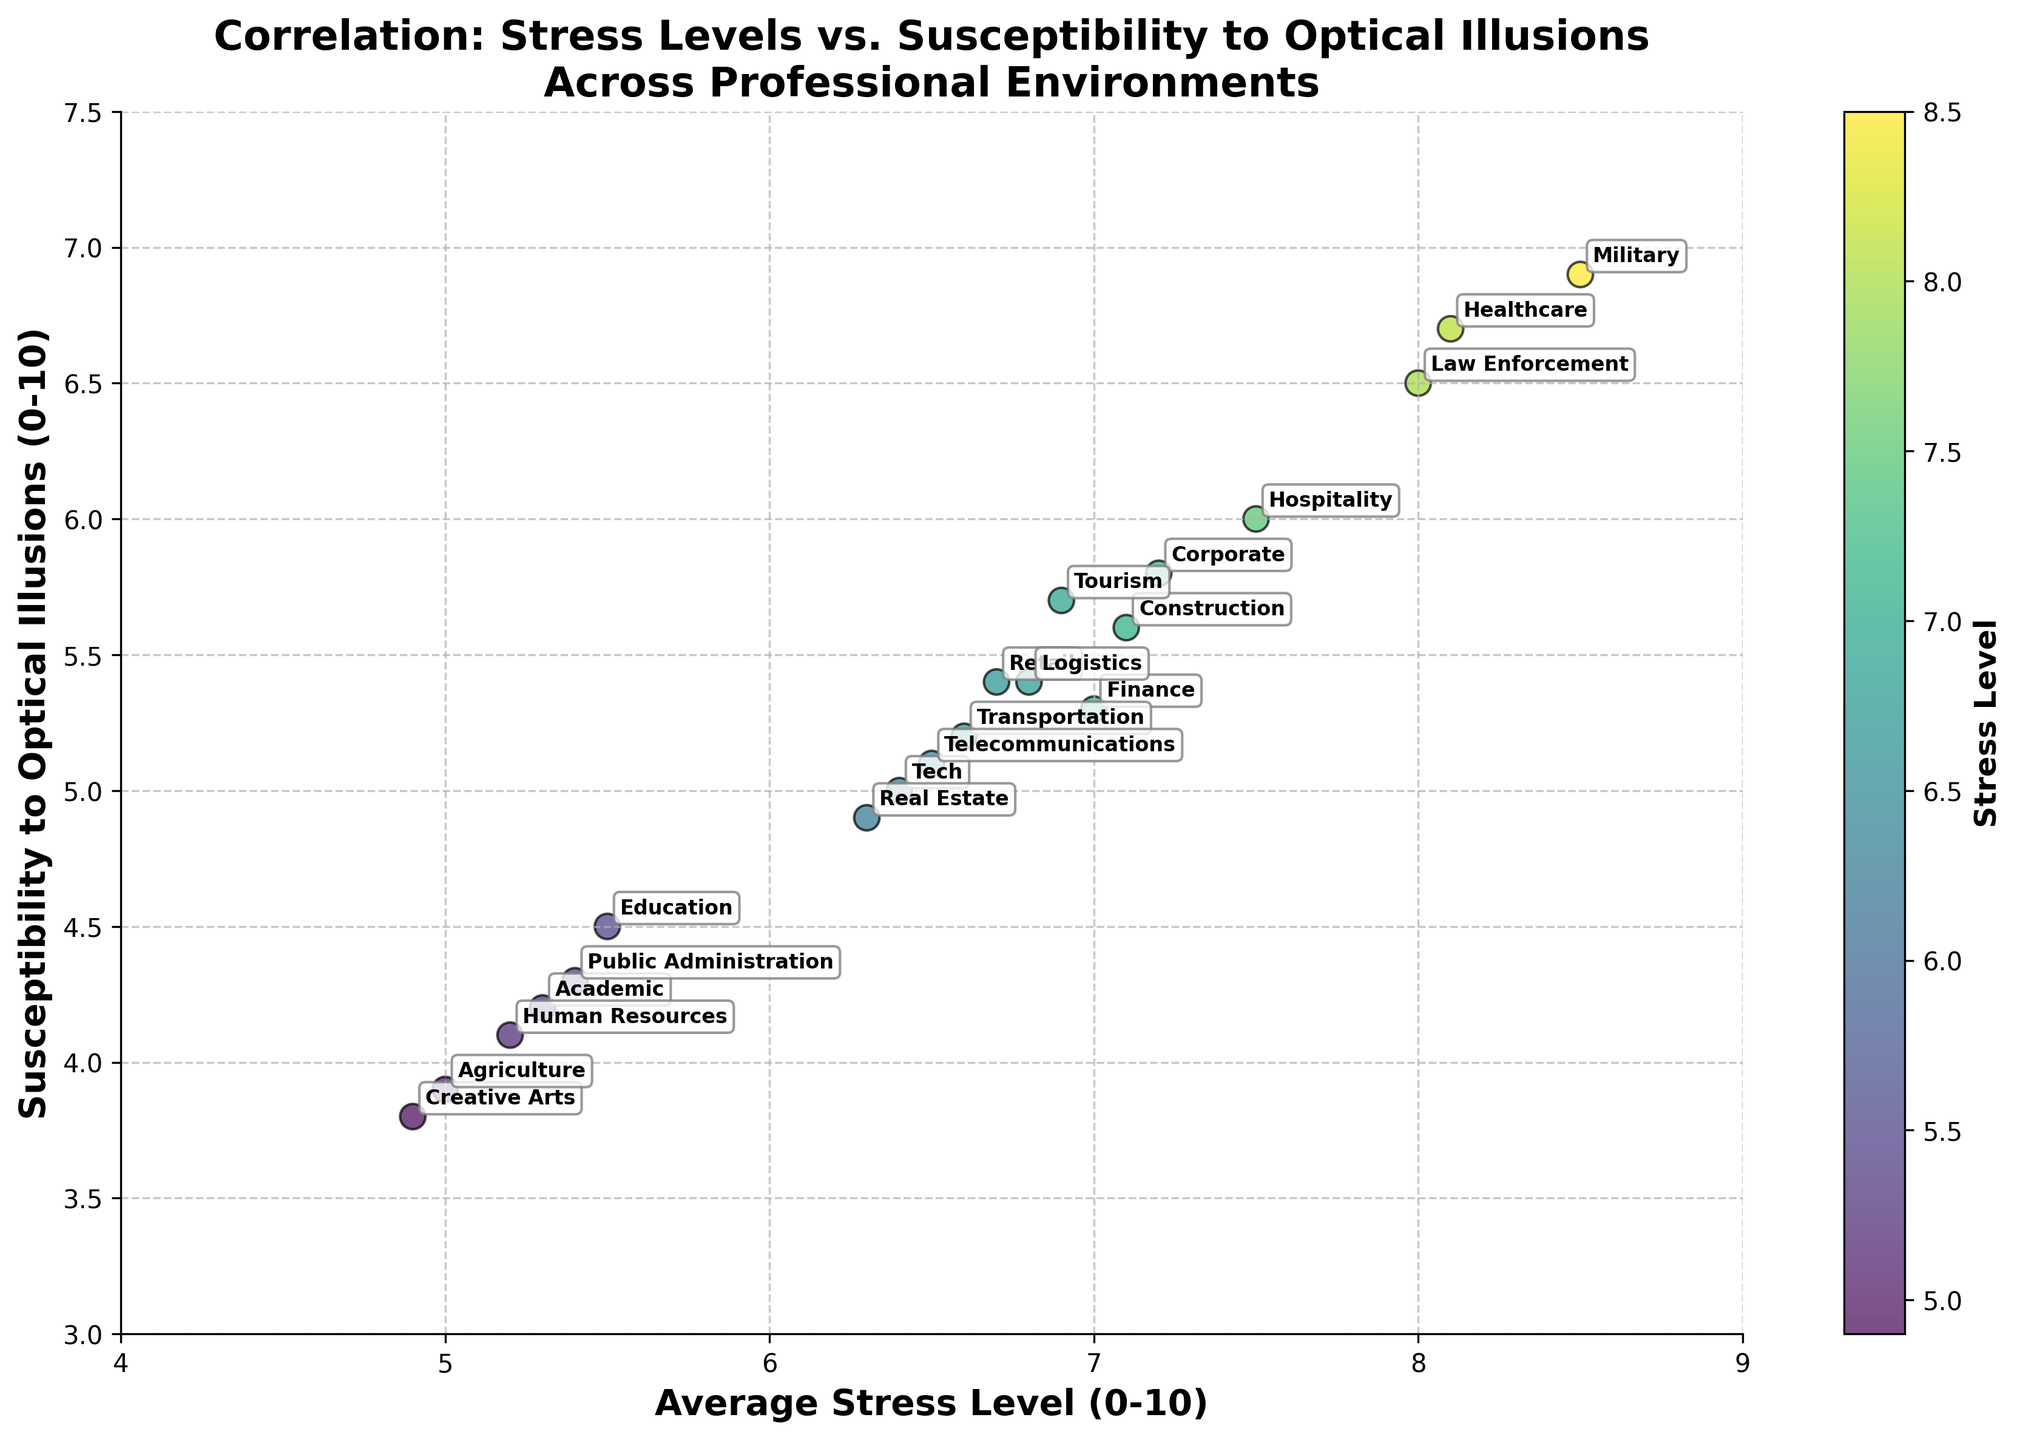How many professional environments are represented in the scatter plot? The scatter plot shows dots annotated with different professional environments. By counting the annotations, we can determine the number of represented environments.
Answer: 20 What is the correlation between stress levels and susceptibility to optical illusions? By observing the trend in the scatter plot, it appears that higher stress levels are associated with higher susceptibility to optical illusions, indicating a positive correlation.
Answer: Positive correlation Which professional environment has the highest average stress level? Look at the data points along the x-axis labeled with average stress levels. Identify the point with the highest x-axis value and note its annotation.
Answer: Military Which professional environment has the lowest susceptibility to optical illusions? Look at the data points along the y-axis labeled with susceptibility to optical illusions. Identify the point with the lowest y-axis value and note its annotation.
Answer: Creative Arts What is the average stress level of environments with susceptibility to optical illusions greater than 6? Identify the data points where the y-axis value is greater than 6 and calculate the average of their corresponding x-axis values. These environments are Healthcare, Law Enforcement, and Military with stress levels of 8.1, 8, and 8.5 respectively. Average: (8.1 + 8 + 8.5) / 3 = 8.2.
Answer: 8.2 Compare the susceptibility to optical illusions between Healthcare and Academic environments. Find and compare the y-axis values for Healthcare and Academic annotations. Healthcare has a susceptibility value of 6.7, whereas Academic has 4.2.
Answer: Healthcare > Academic Which two professional environments have the closest average stress levels? Identify the stress level data points that are nearest to each other along the x-axis. Corporate (7.2) and Construction (7.1) have the closest stress levels, with a difference of 0.1.
Answer: Corporate and Construction How does the stress level of Hospitality compare to Transportation? Compare the x-axis values for Hospitality (7.5) and Transportation (6.6).
Answer: Higher What is the difference in susceptibility to optical illusions between Finance and Real Estate environments? Finance has a susceptibility value of 5.3, and Real Estate has 4.9. The difference is 5.3 - 4.9 = 0.4.
Answer: 0.4 What professional environments have an average stress level below 5.5 and susceptibility to optical illusions below 4? Look for data points with an x-axis value less than 5.5 and a y-axis value less than 4. These environments are Creative Arts (4.9, 3.8) and Agriculture (5.0, 3.9).
Answer: Creative Arts and Agriculture 